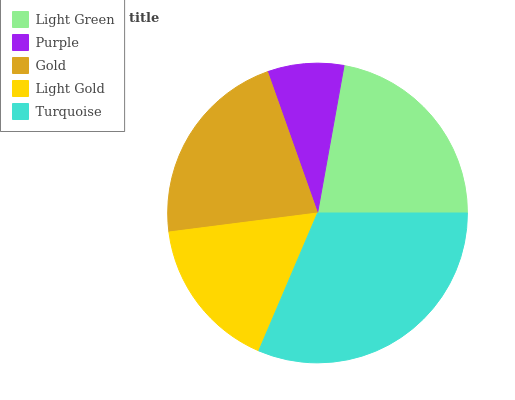Is Purple the minimum?
Answer yes or no. Yes. Is Turquoise the maximum?
Answer yes or no. Yes. Is Gold the minimum?
Answer yes or no. No. Is Gold the maximum?
Answer yes or no. No. Is Gold greater than Purple?
Answer yes or no. Yes. Is Purple less than Gold?
Answer yes or no. Yes. Is Purple greater than Gold?
Answer yes or no. No. Is Gold less than Purple?
Answer yes or no. No. Is Gold the high median?
Answer yes or no. Yes. Is Gold the low median?
Answer yes or no. Yes. Is Turquoise the high median?
Answer yes or no. No. Is Purple the low median?
Answer yes or no. No. 